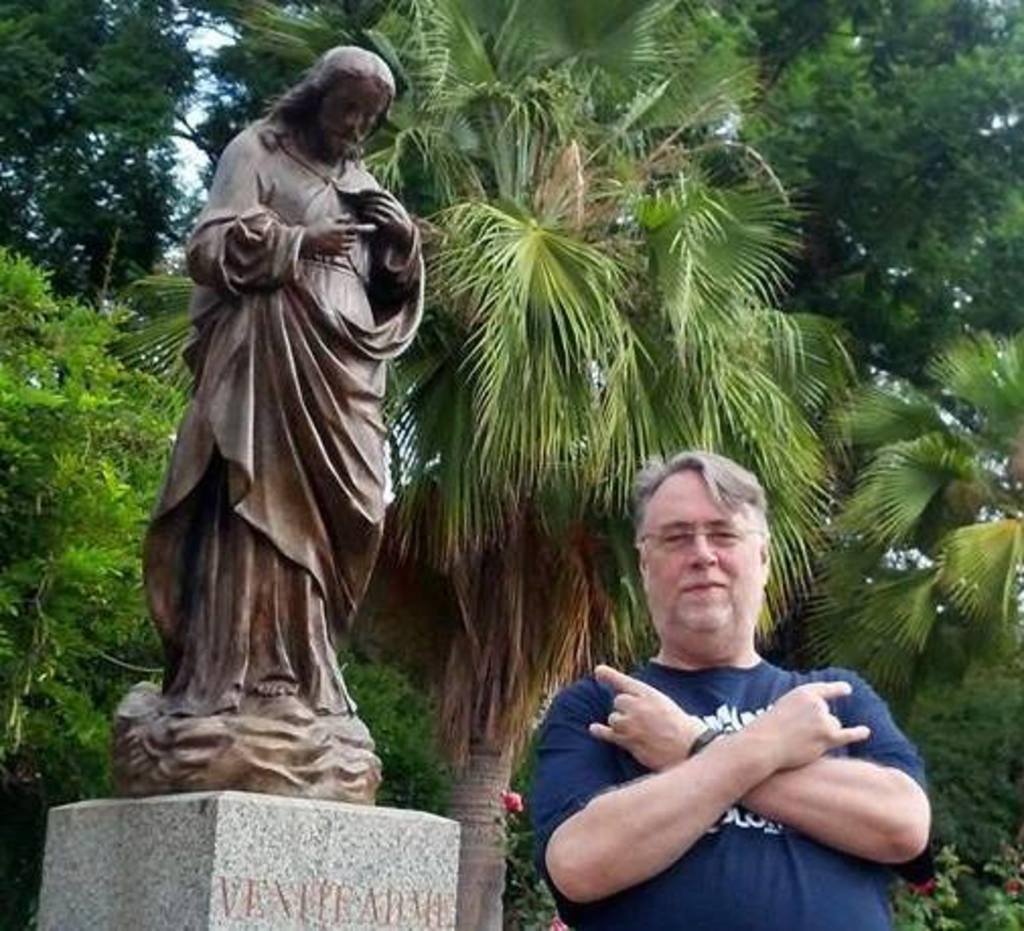What is the main subject in the image? There is a man standing in the image. What else can be seen in the image besides the man? There is a sculpture on a platform in the image. What type of natural environment is visible in the background of the image? There are trees in the background of the image. What is visible in the sky in the background of the image? The sky is visible in the background of the image. What type of robin can be seen flying in the image? There is no robin present in the image; it features a man standing and a sculpture on a platform. Is there a cannon visible in the image? No, there is no cannon present in the image. 